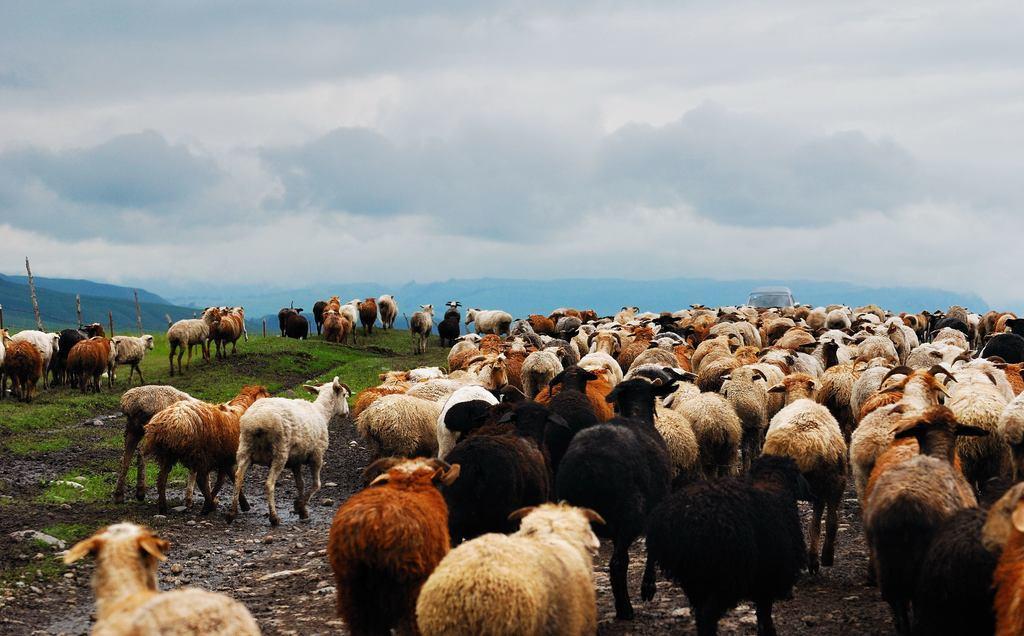Please provide a concise description of this image. In this image I can see group of animals. They are in black,white and brown color. Back Side I can see mountains and wooden logs. The sky is in white color. 